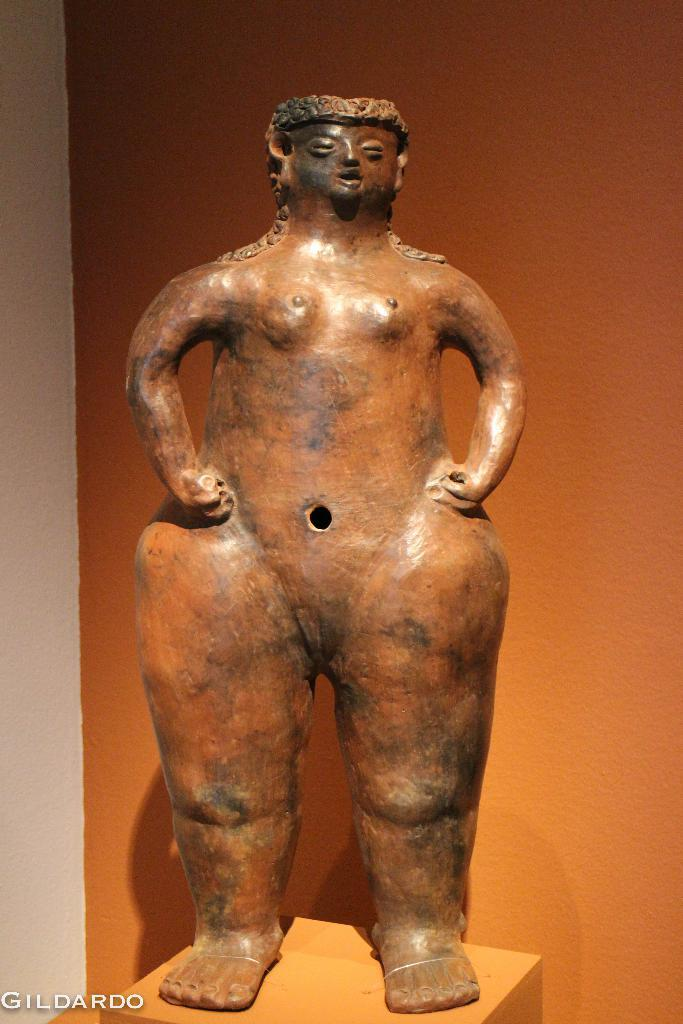What is the main subject in the image? There is a statue in the image. What is the statue resting on? The statue is on a box. What can be seen in the background of the image? There is a brown color wall in the background of the image. Where is the text located in the image? The text is at the bottom left corner of the image. Is there a parcel being delivered in the image? There is no parcel or delivery depicted in the image. How does the rain affect the statue in the image? There is no rain present in the image, so it does not affect the statue. 